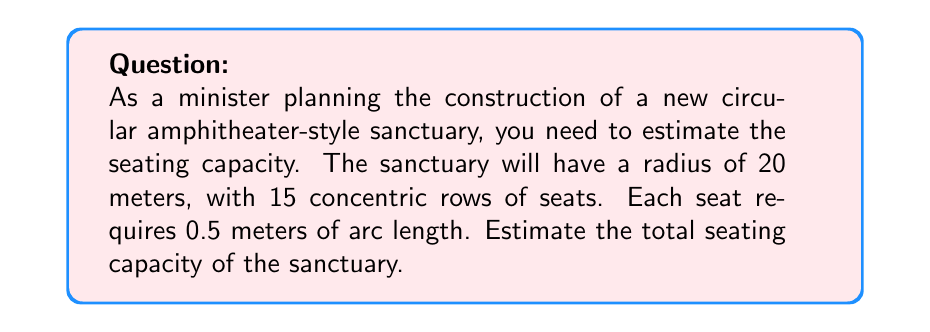Solve this math problem. To solve this problem, we'll follow these steps:

1) First, we need to calculate the circumference of each row. The formula for circumference is:

   $$C = 2\pi r$$

   where $r$ is the radius.

2) The radius for each row will decrease as we move inward. The outermost row has a radius of 20 meters, and each subsequent row is approximately 1 meter closer to the center (assuming 0.5m for the seat depth and 0.5m for walking space).

3) We can calculate the circumference for each row:
   Row 1 (outermost): $$C_1 = 2\pi(20) \approx 125.66m$$
   Row 2: $$C_2 = 2\pi(19) \approx 119.38m$$
   ...
   Row 15 (innermost): $$C_{15} = 2\pi(6) \approx 37.70m$$

4) To find the number of seats in each row, we divide the circumference by the space required for each seat (0.5m):

   $$\text{Seats in row} = \frac{\text{Circumference}}{0.5}$$

5) Calculating for each row:
   Row 1: $$\frac{125.66}{0.5} \approx 251 \text{ seats}$$
   Row 2: $$\frac{119.38}{0.5} \approx 239 \text{ seats}$$
   ...
   Row 15: $$\frac{37.70}{0.5} \approx 75 \text{ seats}$$

6) The total seating capacity is the sum of seats in all rows. Instead of calculating each row individually, we can estimate using the average of the first and last row:

   $$\text{Average seats per row} = \frac{251 + 75}{2} = 163$$

7) Multiply this by the number of rows:

   $$\text{Total seats} \approx 163 \times 15 = 2,445$$

This estimation method gives us a reasonable approximation without needing to calculate each row precisely.
Answer: The estimated seating capacity of the circular amphitheater-style sanctuary is approximately 2,445 seats. 